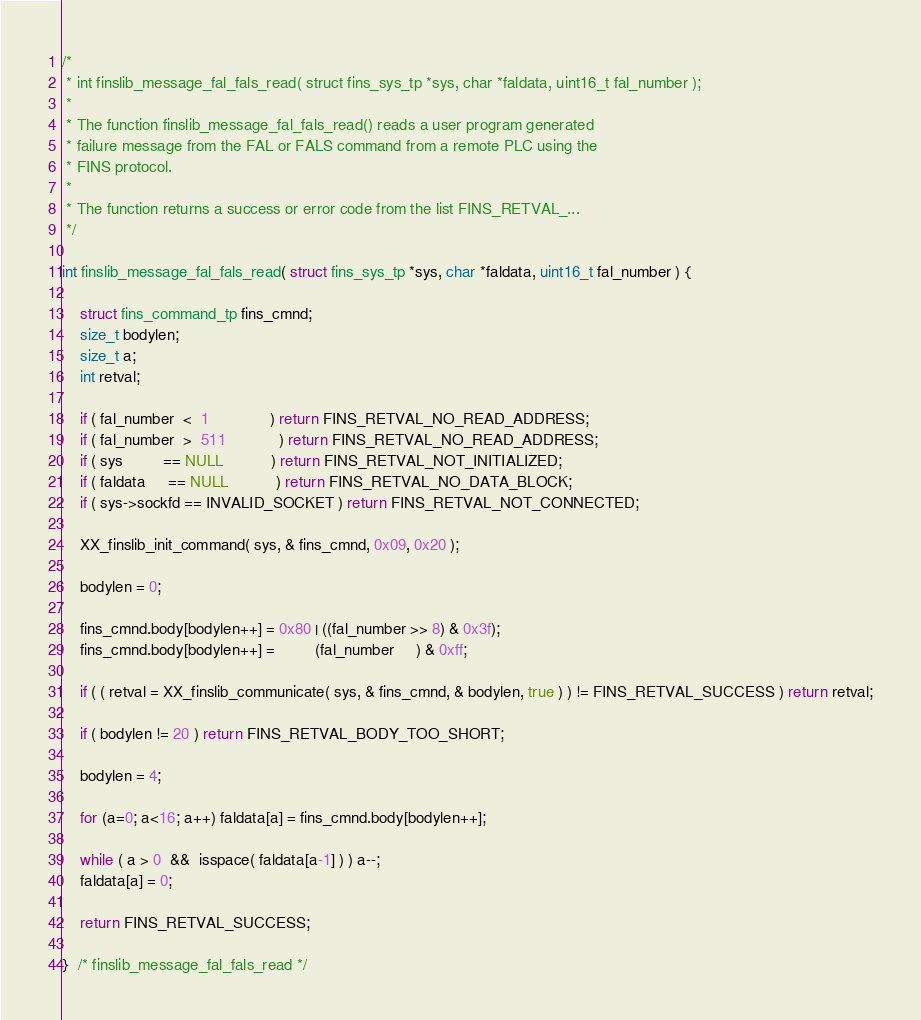<code> <loc_0><loc_0><loc_500><loc_500><_C_>/*
 * int finslib_message_fal_fals_read( struct fins_sys_tp *sys, char *faldata, uint16_t fal_number );
 *
 * The function finslib_message_fal_fals_read() reads a user program generated
 * failure message from the FAL or FALS command from a remote PLC using the
 * FINS protocol.
 *
 * The function returns a success or error code from the list FINS_RETVAL_...
 */

int finslib_message_fal_fals_read( struct fins_sys_tp *sys, char *faldata, uint16_t fal_number ) {

	struct fins_command_tp fins_cmnd;
	size_t bodylen;
	size_t a;
	int retval;

	if ( fal_number  <  1              ) return FINS_RETVAL_NO_READ_ADDRESS;
	if ( fal_number  >  511            ) return FINS_RETVAL_NO_READ_ADDRESS;
	if ( sys         == NULL           ) return FINS_RETVAL_NOT_INITIALIZED;
	if ( faldata     == NULL           ) return FINS_RETVAL_NO_DATA_BLOCK;
	if ( sys->sockfd == INVALID_SOCKET ) return FINS_RETVAL_NOT_CONNECTED;

	XX_finslib_init_command( sys, & fins_cmnd, 0x09, 0x20 );

	bodylen = 0;

	fins_cmnd.body[bodylen++] = 0x80 | ((fal_number >> 8) & 0x3f);
	fins_cmnd.body[bodylen++] =         (fal_number     ) & 0xff;

	if ( ( retval = XX_finslib_communicate( sys, & fins_cmnd, & bodylen, true ) ) != FINS_RETVAL_SUCCESS ) return retval;

	if ( bodylen != 20 ) return FINS_RETVAL_BODY_TOO_SHORT;

	bodylen = 4;

	for (a=0; a<16; a++) faldata[a] = fins_cmnd.body[bodylen++];

	while ( a > 0  &&  isspace( faldata[a-1] ) ) a--;
	faldata[a] = 0;

	return FINS_RETVAL_SUCCESS;

}  /* finslib_message_fal_fals_read */
</code> 